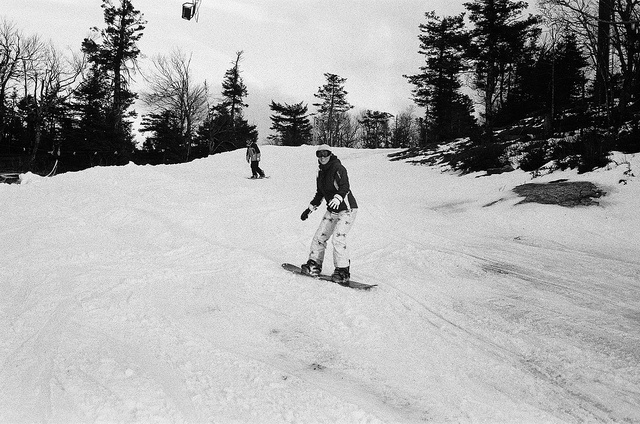Describe the objects in this image and their specific colors. I can see people in white, black, lightgray, darkgray, and gray tones, people in white, black, gray, darkgray, and lightgray tones, snowboard in white, gray, black, darkgray, and lightgray tones, and snowboard in white, gray, lightgray, and black tones in this image. 